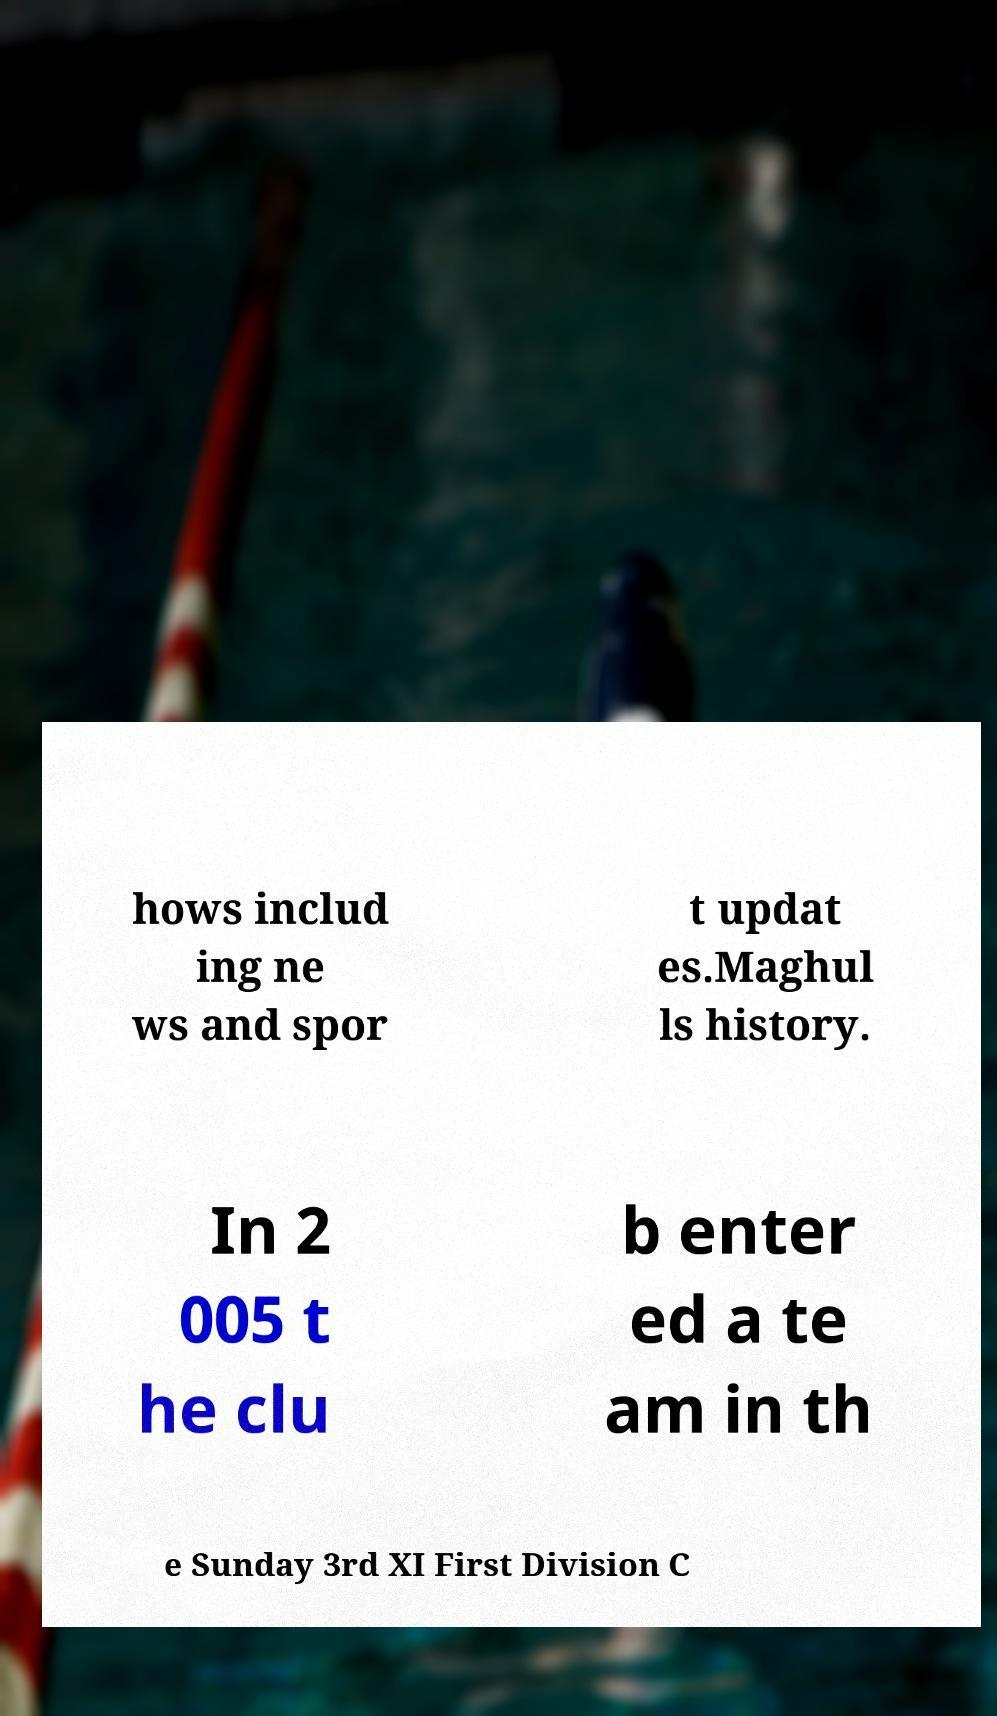For documentation purposes, I need the text within this image transcribed. Could you provide that? hows includ ing ne ws and spor t updat es.Maghul ls history. In 2 005 t he clu b enter ed a te am in th e Sunday 3rd XI First Division C 